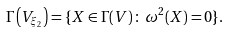<formula> <loc_0><loc_0><loc_500><loc_500>\Gamma \left ( V _ { \xi _ { 2 } } \right ) = \{ X \in \Gamma ( V ) \, \colon \, \omega ^ { 2 } ( X ) = 0 \} .</formula> 